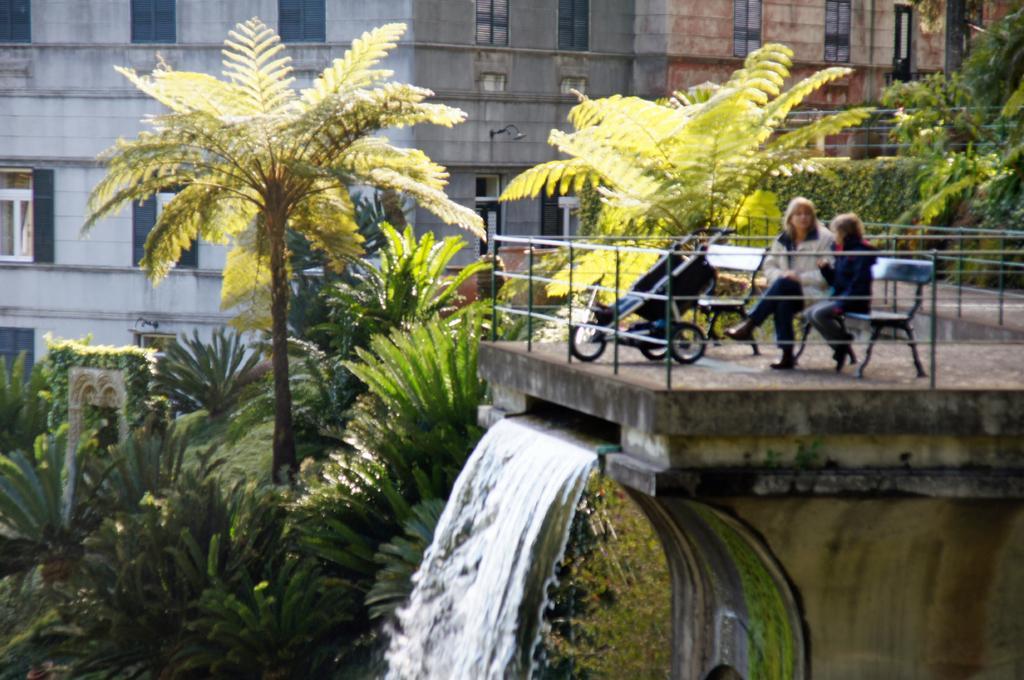In one or two sentences, can you explain what this image depicts? In this image we can see a stroller, bench and two persons are sitting on a bench, fence on the platform and we can see coming out through that platform. In the background there are trees, plants, buildings, windows, light on the wall and electric wires. 